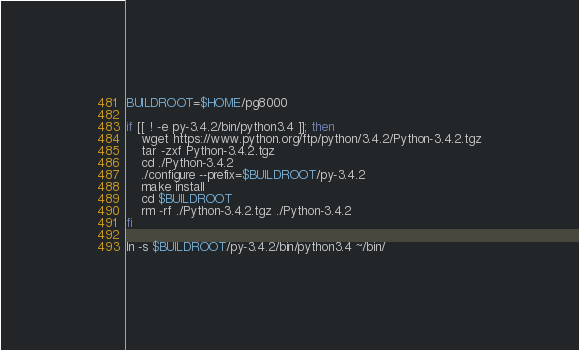<code> <loc_0><loc_0><loc_500><loc_500><_Bash_>BUILDROOT=$HOME/pg8000

if [[ ! -e py-3.4.2/bin/python3.4 ]]; then
    wget https://www.python.org/ftp/python/3.4.2/Python-3.4.2.tgz
    tar -zxf Python-3.4.2.tgz
    cd ./Python-3.4.2
    ./configure --prefix=$BUILDROOT/py-3.4.2
    make install
    cd $BUILDROOT
    rm -rf ./Python-3.4.2.tgz ./Python-3.4.2
fi

ln -s $BUILDROOT/py-3.4.2/bin/python3.4 ~/bin/
</code> 